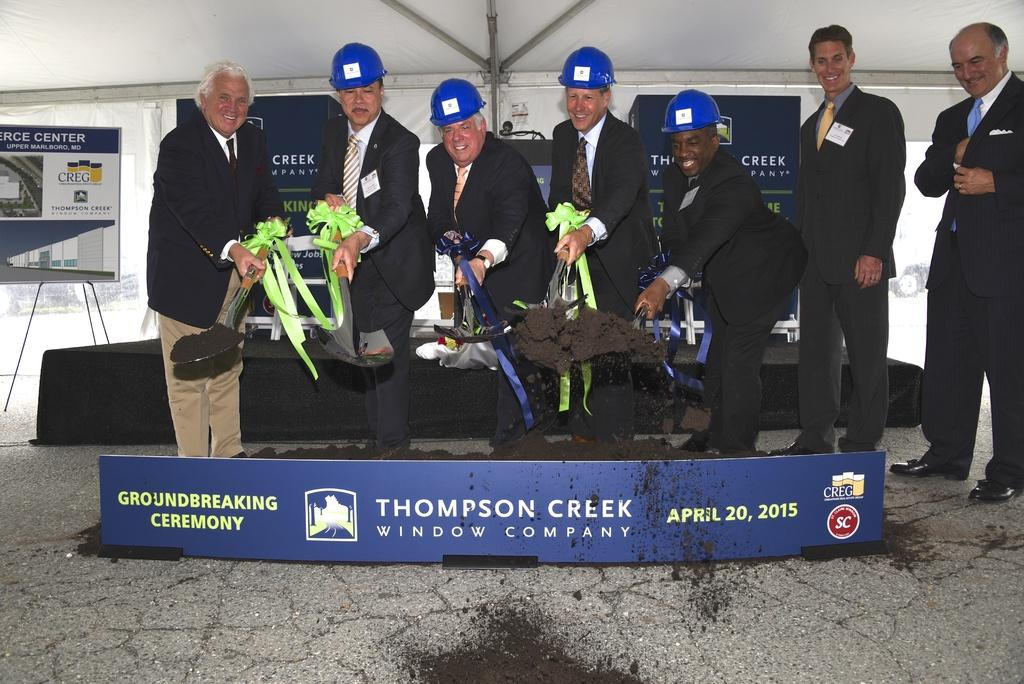What can be observed about the people in the image? There are people standing in the image. What are some of the people holding? Some people are holding objects. What type of signage is present in the image? There are name boards in the image. What else can be seen in the image besides people and name boards? There are poles in the image. How is one of the name boards supported? There is a name board with a stand. Where can the cub be found in the image? There is no cub present in the image. What type of drawer is visible in the image? There are no drawers visible in the image. 